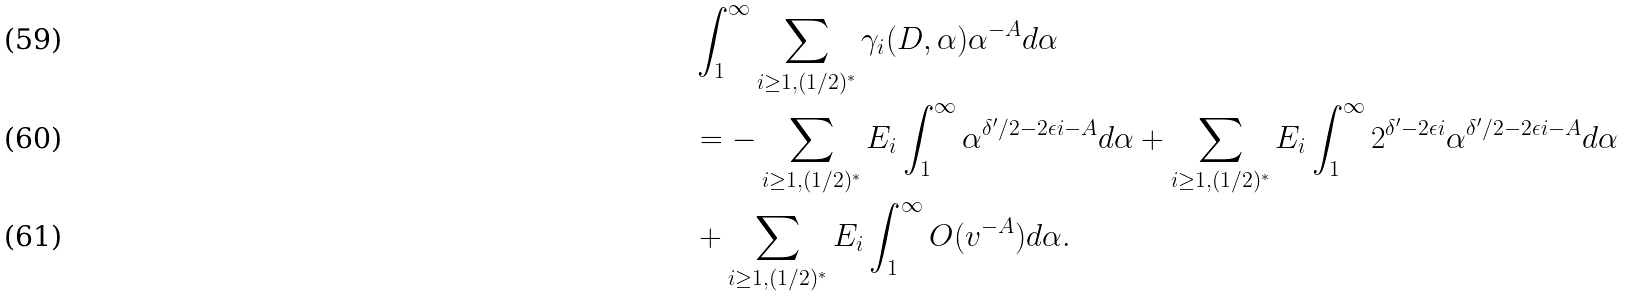<formula> <loc_0><loc_0><loc_500><loc_500>& \int _ { 1 } ^ { \infty } \sum _ { i \geq 1 , ( 1 / 2 ) ^ { * } } \gamma _ { i } ( D , \alpha ) \alpha ^ { - A } d \alpha \\ & = - \sum _ { i \geq 1 , ( 1 / 2 ) ^ { * } } E _ { i } \int _ { 1 } ^ { \infty } \alpha ^ { \delta ^ { \prime } / 2 - 2 \epsilon i - A } d \alpha + \sum _ { i \geq 1 , ( 1 / 2 ) ^ { * } } E _ { i } \int _ { 1 } ^ { \infty } 2 ^ { \delta ^ { \prime } - 2 \epsilon i } \alpha ^ { \delta ^ { \prime } / 2 - 2 \epsilon i - A } d \alpha \\ & + \sum _ { i \geq 1 , ( 1 / 2 ) ^ { * } } E _ { i } \int _ { 1 } ^ { \infty } O ( v ^ { - A } ) d \alpha .</formula> 